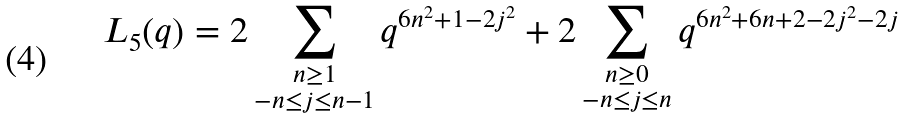<formula> <loc_0><loc_0><loc_500><loc_500>L _ { 5 } ( q ) = 2 \sum _ { \substack { n \geq 1 \\ - n \leq j \leq n - 1 } } q ^ { 6 n ^ { 2 } + 1 - 2 j ^ { 2 } } + 2 \sum _ { \substack { n \geq 0 \\ - n \leq j \leq n } } q ^ { 6 n ^ { 2 } + 6 n + 2 - 2 j ^ { 2 } - 2 j }</formula> 